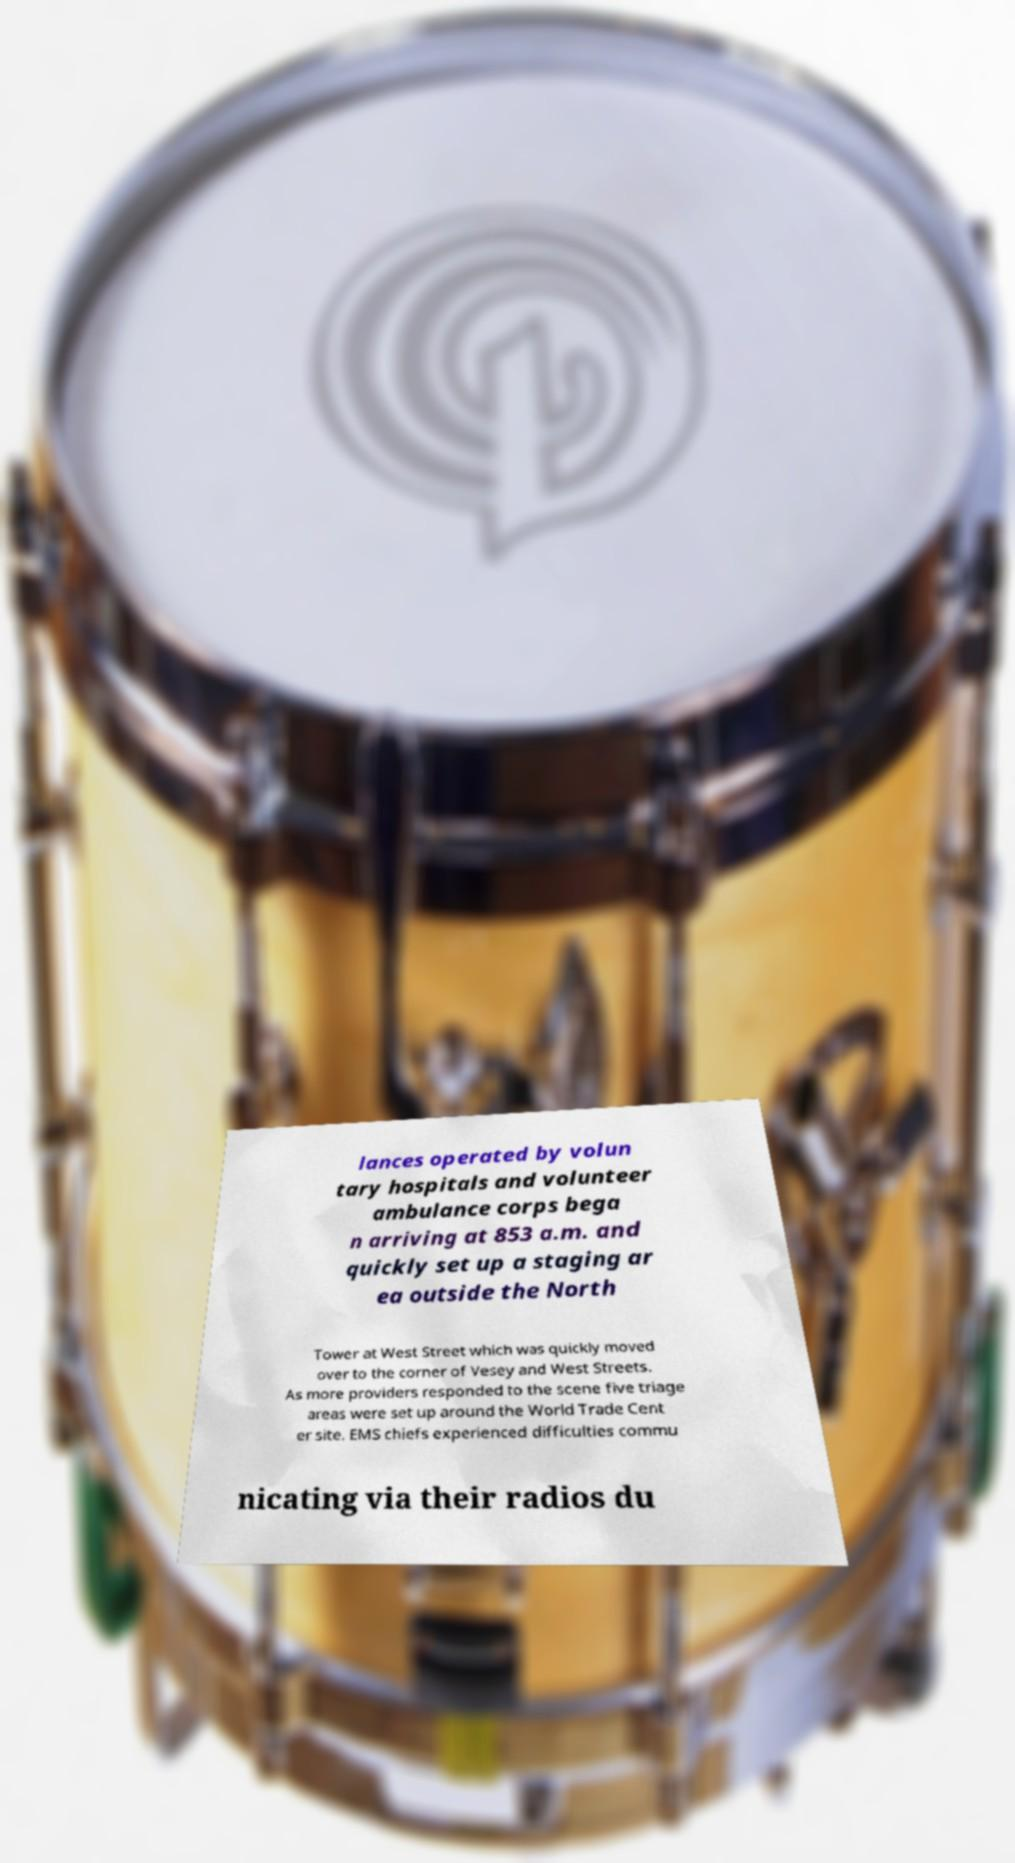Could you extract and type out the text from this image? lances operated by volun tary hospitals and volunteer ambulance corps bega n arriving at 853 a.m. and quickly set up a staging ar ea outside the North Tower at West Street which was quickly moved over to the corner of Vesey and West Streets. As more providers responded to the scene five triage areas were set up around the World Trade Cent er site. EMS chiefs experienced difficulties commu nicating via their radios du 